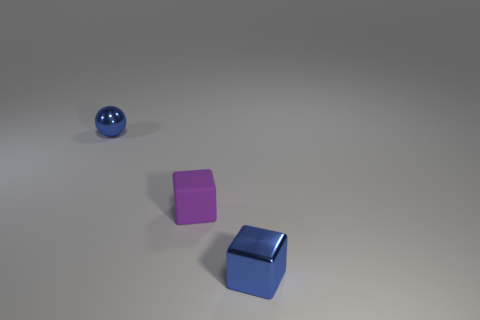Do the purple rubber object and the blue ball have the same size?
Make the answer very short. Yes. Are there fewer matte blocks on the right side of the blue cube than shiny objects that are to the left of the tiny purple thing?
Your answer should be very brief. Yes. How big is the object that is both right of the shiny sphere and behind the small blue cube?
Your answer should be compact. Small. There is a blue metallic object that is right of the blue shiny object that is behind the rubber object; are there any tiny blue blocks in front of it?
Keep it short and to the point. No. Are there any yellow metallic things?
Offer a terse response. No. Are there more metallic objects that are behind the small blue metallic cube than purple rubber cubes behind the small metallic ball?
Your response must be concise. Yes. There is a blue thing that is the same material as the small ball; what size is it?
Offer a terse response. Small. What is the size of the metallic thing that is behind the small object that is in front of the small purple block on the left side of the shiny cube?
Provide a succinct answer. Small. There is a metallic thing that is in front of the small metallic sphere; what is its color?
Provide a short and direct response. Blue. Are there more blue metallic things that are left of the blue ball than big cyan cubes?
Offer a terse response. No. 